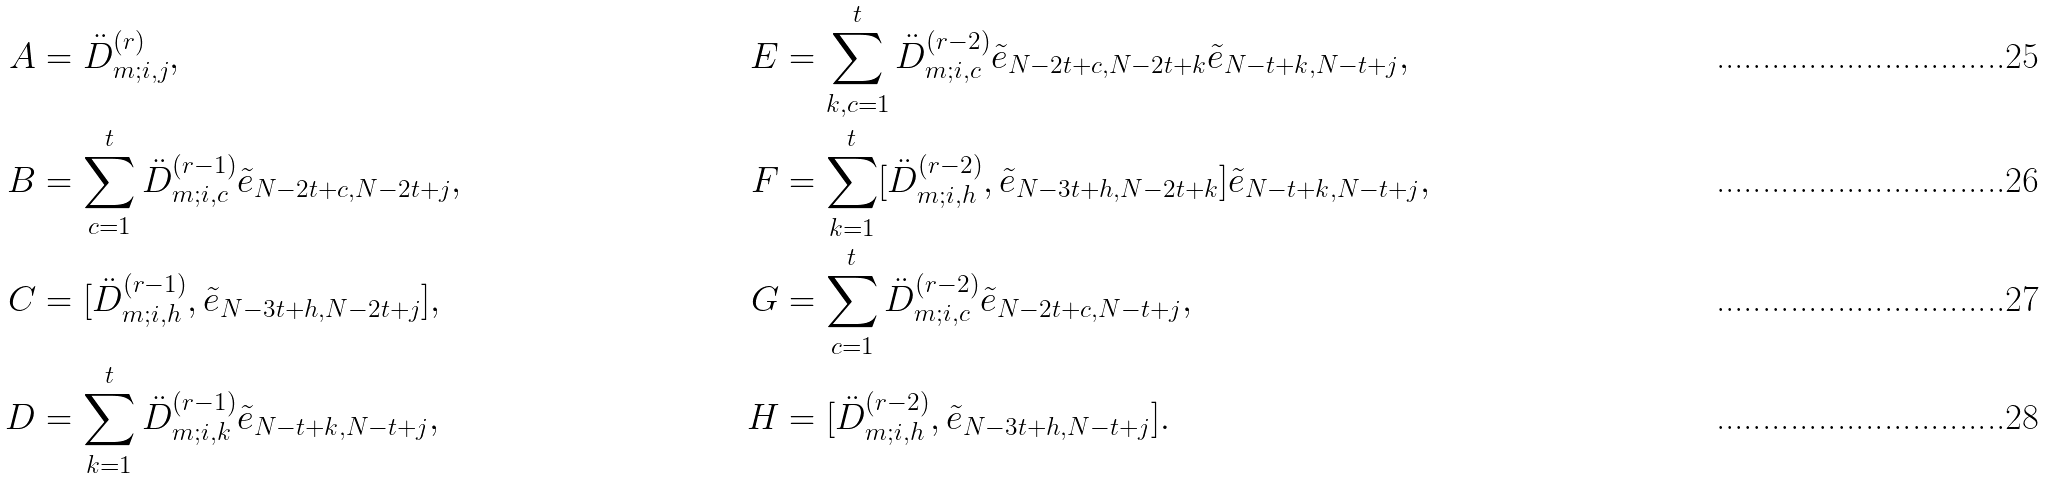<formula> <loc_0><loc_0><loc_500><loc_500>A & = \ddot { D } _ { m ; i , j } ^ { ( r ) } , & E & = \sum _ { k , c = 1 } ^ { t } \ddot { D } _ { m ; i , c } ^ { ( r - 2 ) } \tilde { e } _ { N - 2 t + c , N - 2 t + k } \tilde { e } _ { N - t + k , N - t + j } , \\ B & = \sum _ { c = 1 } ^ { t } \ddot { D } _ { m ; i , c } ^ { ( r - 1 ) } \tilde { e } _ { N - 2 t + c , N - 2 t + j } , & F & = \sum _ { k = 1 } ^ { t } [ \ddot { D } _ { m ; i , h } ^ { ( r - 2 ) } , \tilde { e } _ { N - 3 t + h , N - 2 t + k } ] \tilde { e } _ { N - t + k , N - t + j } , \\ C & = [ \ddot { D } _ { m ; i , h } ^ { ( r - 1 ) } , \tilde { e } _ { N - 3 t + h , N - 2 t + j } ] , & G & = \sum _ { c = 1 } ^ { t } \ddot { D } _ { m ; i , c } ^ { ( r - 2 ) } \tilde { e } _ { N - 2 t + c , N - t + j } , \\ D & = \sum _ { k = 1 } ^ { t } \ddot { D } _ { m ; i , k } ^ { ( r - 1 ) } \tilde { e } _ { N - t + k , N - t + j } , & H & = [ \ddot { D } _ { m ; i , h } ^ { ( r - 2 ) } , \tilde { e } _ { N - 3 t + h , N - t + j } ] .</formula> 